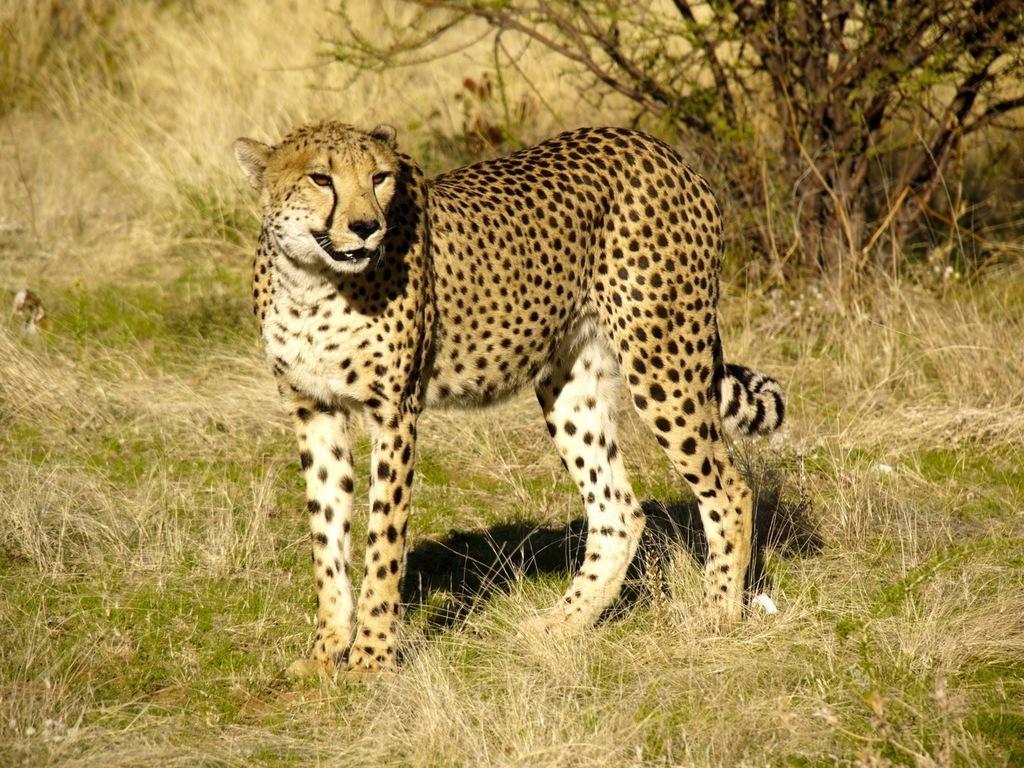Describe this image in one or two sentences. Here in this picture we can see a cheetah present on the ground, which is present on the ground over there and behind it we can see plants present over there. 